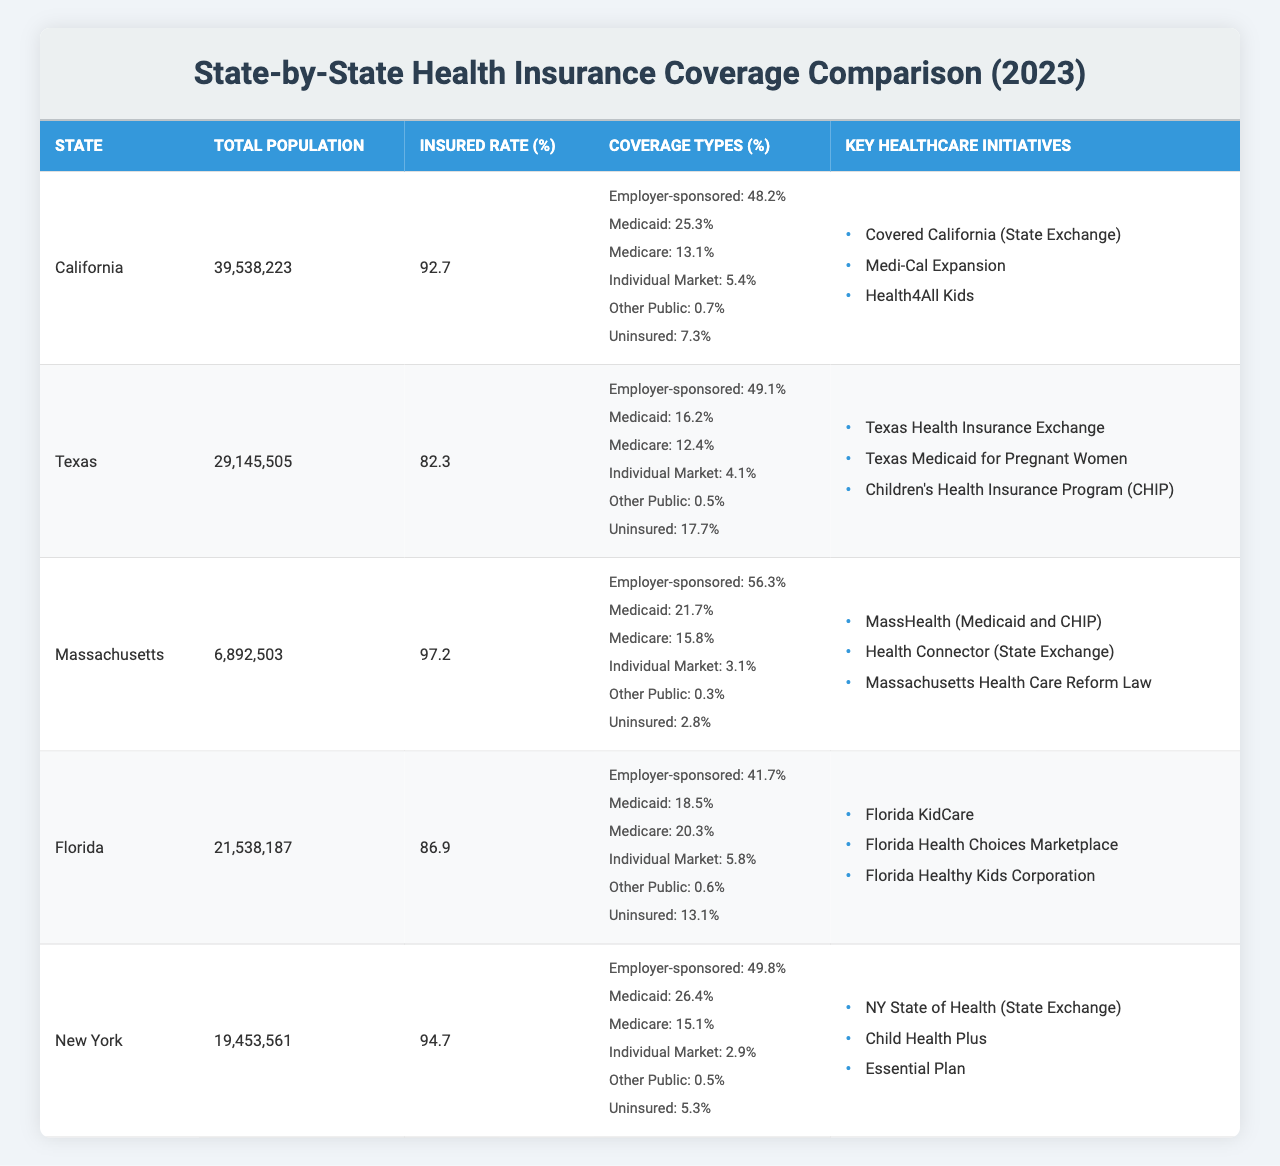What is the insured rate for Massachusetts? The table shows the insured rate for each state. For Massachusetts, the insured rate is explicitly listed as 97.2%.
Answer: 97.2% Which state has the highest rate of uninsured individuals? By reviewing the uninsured rates for each state, Texas has the highest at 17.7%.
Answer: Texas What is the total population of California? The total population for California is provided in the table, which shows 39,538,223.
Answer: 39,538,223 How does the employer-sponsored coverage in Florida compare to that in California? Florida has an employer-sponsored coverage rate of 41.7%, while California has a rate of 48.2%. To find the difference, we subtract: 48.2% - 41.7% = 6.5%. Therefore, California has a higher employer-sponsored coverage by 6.5%.
Answer: 6.5% Is the percentage of Medicaid coverage higher in New York than in Texas? The table shows that New York's Medicaid coverage is 26.4%, while Texas's Medicaid coverage is 16.2%. Since 26.4% is greater than 16.2%, the statement is true.
Answer: Yes What is the average uninsured rate across all five states? First, we list the uninsured rates: California 7.3%, Texas 17.7%, Massachusetts 2.8%, Florida 13.1%, and New York 5.3%. Next, we sum these rates: 7.3 + 17.7 + 2.8 + 13.1 + 5.3 = 46.2%. Finally, we divide by the number of states (5): 46.2% / 5 = 9.24%.
Answer: 9.24% Which state has the highest Medicare coverage percentage? By checking the Medicare coverage percentages in the table, Florida has the highest at 20.3%.
Answer: Florida What is the difference in the total number of insured individuals between Massachusetts and Texas? First, we find the number of insured individuals for both states. For Texas, insured rate is 82.3% of 29,145,505 = about 23,986,046. For Massachusetts, insured rate is 97.2% of 6,892,503 = about 6,698,112. Now, we calculate the difference: 23,986,046 - 6,698,112 = 17,287,934.
Answer: 17,287,934 Does California have the lowest uninsured rate among the five states? The chart lists California's uninsured rate as 7.3%, and we compare it with the other states: Texas (17.7%), Massachusetts (2.8%), Florida (13.1%), New York (5.3%). Since 7.3% is greater than Massachusetts (2.8%) and New York (5.3%) but lower than Texas and Florida, California does not have the lowest uninsured rate.
Answer: No What percentage of coverage comes from the individual market in New York? In the table, New York's individual market coverage is listed as 2.9%.
Answer: 2.9% What are the key healthcare initiatives for Florida? The table lists Florida's key healthcare initiatives, which are: Florida KidCare, Florida Health Choices Marketplace, and Florida Healthy Kids Corporation.
Answer: Florida KidCare, Florida Health Choices Marketplace, Florida Healthy Kids Corporation 